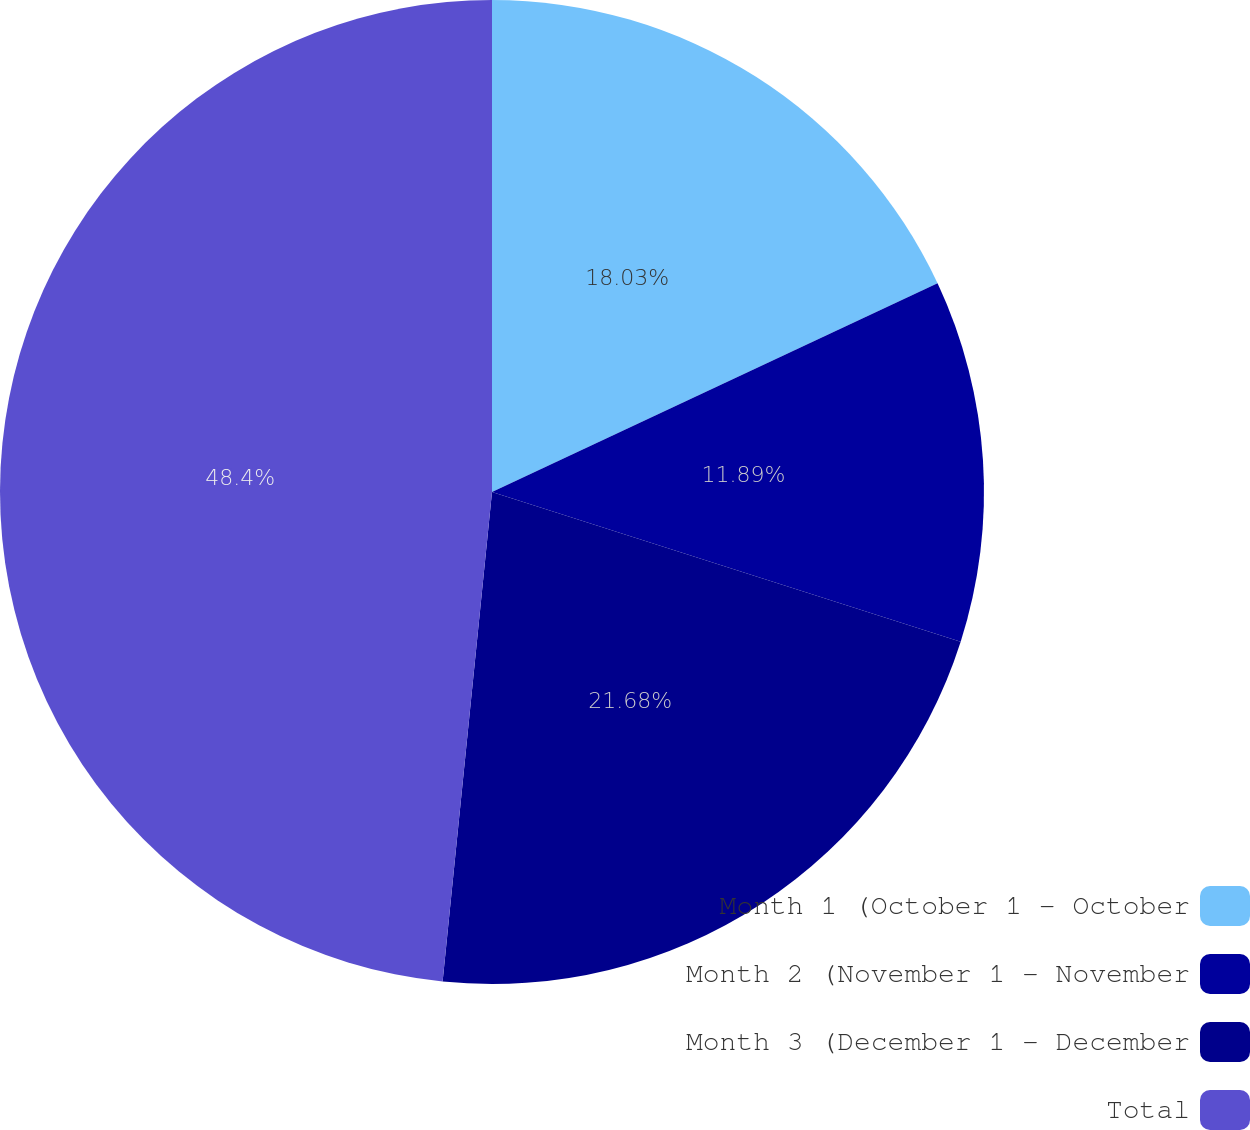Convert chart. <chart><loc_0><loc_0><loc_500><loc_500><pie_chart><fcel>Month 1 (October 1 - October<fcel>Month 2 (November 1 - November<fcel>Month 3 (December 1 - December<fcel>Total<nl><fcel>18.03%<fcel>11.89%<fcel>21.68%<fcel>48.4%<nl></chart> 